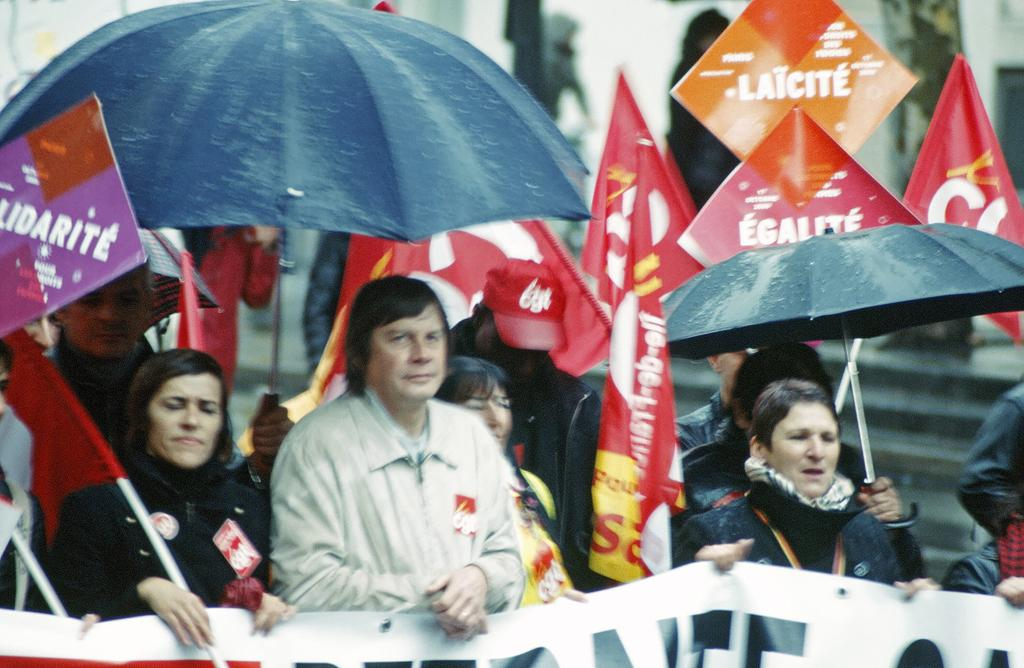How many people are visible in the image? There are many people standing in the image. What are the people holding in their hands? The people are holding flags, umbrellas, and placards. What is the purpose of the banner in the image? The purpose of the banner is not specified, but it may be related to the event or gathering. What architectural feature can be seen in the background of the image? There are steps in the background of the image. How would you describe the background of the image? The background of the image is blurry. What type of fang can be seen in the image? There is no fang present in the image. How does the sense of smell contribute to the event in the image? The sense of smell is not mentioned or depicted in the image, so it cannot be determined how it contributes to the event. 